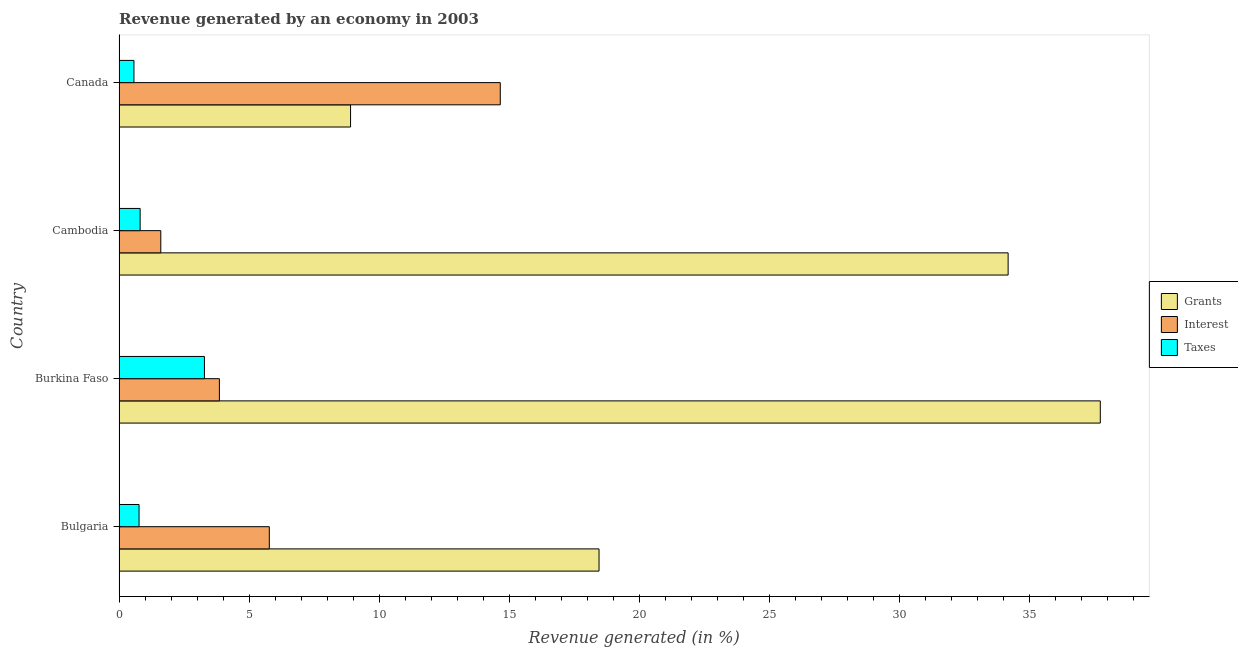How many groups of bars are there?
Keep it short and to the point. 4. Are the number of bars on each tick of the Y-axis equal?
Give a very brief answer. Yes. How many bars are there on the 3rd tick from the bottom?
Your answer should be very brief. 3. What is the label of the 1st group of bars from the top?
Offer a very short reply. Canada. What is the percentage of revenue generated by taxes in Canada?
Give a very brief answer. 0.57. Across all countries, what is the maximum percentage of revenue generated by grants?
Your answer should be compact. 37.71. Across all countries, what is the minimum percentage of revenue generated by grants?
Keep it short and to the point. 8.9. In which country was the percentage of revenue generated by taxes minimum?
Ensure brevity in your answer.  Canada. What is the total percentage of revenue generated by grants in the graph?
Offer a terse response. 99.23. What is the difference between the percentage of revenue generated by interest in Bulgaria and that in Cambodia?
Make the answer very short. 4.17. What is the difference between the percentage of revenue generated by taxes in Bulgaria and the percentage of revenue generated by grants in Canada?
Your answer should be compact. -8.13. What is the average percentage of revenue generated by interest per country?
Your answer should be very brief. 6.47. What is the difference between the percentage of revenue generated by interest and percentage of revenue generated by taxes in Bulgaria?
Provide a succinct answer. 5.01. In how many countries, is the percentage of revenue generated by interest greater than 4 %?
Your answer should be very brief. 2. What is the ratio of the percentage of revenue generated by interest in Cambodia to that in Canada?
Keep it short and to the point. 0.11. Is the difference between the percentage of revenue generated by grants in Bulgaria and Cambodia greater than the difference between the percentage of revenue generated by interest in Bulgaria and Cambodia?
Your answer should be compact. No. What is the difference between the highest and the second highest percentage of revenue generated by taxes?
Offer a terse response. 2.47. What is the difference between the highest and the lowest percentage of revenue generated by interest?
Your answer should be compact. 13.05. What does the 1st bar from the top in Burkina Faso represents?
Your answer should be compact. Taxes. What does the 2nd bar from the bottom in Bulgaria represents?
Keep it short and to the point. Interest. Is it the case that in every country, the sum of the percentage of revenue generated by grants and percentage of revenue generated by interest is greater than the percentage of revenue generated by taxes?
Provide a short and direct response. Yes. How many bars are there?
Provide a succinct answer. 12. Are all the bars in the graph horizontal?
Give a very brief answer. Yes. What is the difference between two consecutive major ticks on the X-axis?
Offer a very short reply. 5. Does the graph contain any zero values?
Provide a short and direct response. No. Where does the legend appear in the graph?
Provide a succinct answer. Center right. What is the title of the graph?
Make the answer very short. Revenue generated by an economy in 2003. What is the label or title of the X-axis?
Ensure brevity in your answer.  Revenue generated (in %). What is the label or title of the Y-axis?
Your answer should be very brief. Country. What is the Revenue generated (in %) of Grants in Bulgaria?
Your answer should be compact. 18.45. What is the Revenue generated (in %) of Interest in Bulgaria?
Provide a succinct answer. 5.78. What is the Revenue generated (in %) in Taxes in Bulgaria?
Offer a terse response. 0.77. What is the Revenue generated (in %) in Grants in Burkina Faso?
Keep it short and to the point. 37.71. What is the Revenue generated (in %) in Interest in Burkina Faso?
Keep it short and to the point. 3.86. What is the Revenue generated (in %) in Taxes in Burkina Faso?
Provide a succinct answer. 3.28. What is the Revenue generated (in %) of Grants in Cambodia?
Make the answer very short. 34.17. What is the Revenue generated (in %) in Interest in Cambodia?
Your answer should be very brief. 1.6. What is the Revenue generated (in %) in Taxes in Cambodia?
Ensure brevity in your answer.  0.81. What is the Revenue generated (in %) in Grants in Canada?
Your answer should be very brief. 8.9. What is the Revenue generated (in %) in Interest in Canada?
Give a very brief answer. 14.65. What is the Revenue generated (in %) in Taxes in Canada?
Your answer should be very brief. 0.57. Across all countries, what is the maximum Revenue generated (in %) of Grants?
Offer a terse response. 37.71. Across all countries, what is the maximum Revenue generated (in %) of Interest?
Your answer should be very brief. 14.65. Across all countries, what is the maximum Revenue generated (in %) of Taxes?
Offer a very short reply. 3.28. Across all countries, what is the minimum Revenue generated (in %) in Grants?
Make the answer very short. 8.9. Across all countries, what is the minimum Revenue generated (in %) in Interest?
Ensure brevity in your answer.  1.6. Across all countries, what is the minimum Revenue generated (in %) of Taxes?
Ensure brevity in your answer.  0.57. What is the total Revenue generated (in %) of Grants in the graph?
Your answer should be very brief. 99.23. What is the total Revenue generated (in %) in Interest in the graph?
Your answer should be compact. 25.89. What is the total Revenue generated (in %) of Taxes in the graph?
Give a very brief answer. 5.43. What is the difference between the Revenue generated (in %) in Grants in Bulgaria and that in Burkina Faso?
Provide a short and direct response. -19.27. What is the difference between the Revenue generated (in %) in Interest in Bulgaria and that in Burkina Faso?
Your answer should be very brief. 1.92. What is the difference between the Revenue generated (in %) in Taxes in Bulgaria and that in Burkina Faso?
Provide a succinct answer. -2.51. What is the difference between the Revenue generated (in %) of Grants in Bulgaria and that in Cambodia?
Give a very brief answer. -15.72. What is the difference between the Revenue generated (in %) of Interest in Bulgaria and that in Cambodia?
Provide a short and direct response. 4.17. What is the difference between the Revenue generated (in %) of Taxes in Bulgaria and that in Cambodia?
Provide a succinct answer. -0.04. What is the difference between the Revenue generated (in %) in Grants in Bulgaria and that in Canada?
Your answer should be very brief. 9.55. What is the difference between the Revenue generated (in %) of Interest in Bulgaria and that in Canada?
Give a very brief answer. -8.88. What is the difference between the Revenue generated (in %) in Taxes in Bulgaria and that in Canada?
Make the answer very short. 0.2. What is the difference between the Revenue generated (in %) of Grants in Burkina Faso and that in Cambodia?
Provide a succinct answer. 3.54. What is the difference between the Revenue generated (in %) in Interest in Burkina Faso and that in Cambodia?
Ensure brevity in your answer.  2.25. What is the difference between the Revenue generated (in %) in Taxes in Burkina Faso and that in Cambodia?
Offer a very short reply. 2.47. What is the difference between the Revenue generated (in %) in Grants in Burkina Faso and that in Canada?
Your answer should be very brief. 28.82. What is the difference between the Revenue generated (in %) of Interest in Burkina Faso and that in Canada?
Your response must be concise. -10.8. What is the difference between the Revenue generated (in %) in Taxes in Burkina Faso and that in Canada?
Give a very brief answer. 2.71. What is the difference between the Revenue generated (in %) of Grants in Cambodia and that in Canada?
Provide a succinct answer. 25.27. What is the difference between the Revenue generated (in %) in Interest in Cambodia and that in Canada?
Offer a terse response. -13.05. What is the difference between the Revenue generated (in %) of Taxes in Cambodia and that in Canada?
Offer a very short reply. 0.24. What is the difference between the Revenue generated (in %) of Grants in Bulgaria and the Revenue generated (in %) of Interest in Burkina Faso?
Offer a terse response. 14.59. What is the difference between the Revenue generated (in %) of Grants in Bulgaria and the Revenue generated (in %) of Taxes in Burkina Faso?
Ensure brevity in your answer.  15.17. What is the difference between the Revenue generated (in %) in Interest in Bulgaria and the Revenue generated (in %) in Taxes in Burkina Faso?
Make the answer very short. 2.49. What is the difference between the Revenue generated (in %) in Grants in Bulgaria and the Revenue generated (in %) in Interest in Cambodia?
Provide a succinct answer. 16.84. What is the difference between the Revenue generated (in %) in Grants in Bulgaria and the Revenue generated (in %) in Taxes in Cambodia?
Provide a short and direct response. 17.64. What is the difference between the Revenue generated (in %) of Interest in Bulgaria and the Revenue generated (in %) of Taxes in Cambodia?
Offer a very short reply. 4.96. What is the difference between the Revenue generated (in %) of Grants in Bulgaria and the Revenue generated (in %) of Interest in Canada?
Your answer should be compact. 3.8. What is the difference between the Revenue generated (in %) of Grants in Bulgaria and the Revenue generated (in %) of Taxes in Canada?
Offer a very short reply. 17.87. What is the difference between the Revenue generated (in %) of Interest in Bulgaria and the Revenue generated (in %) of Taxes in Canada?
Provide a short and direct response. 5.2. What is the difference between the Revenue generated (in %) in Grants in Burkina Faso and the Revenue generated (in %) in Interest in Cambodia?
Provide a short and direct response. 36.11. What is the difference between the Revenue generated (in %) in Grants in Burkina Faso and the Revenue generated (in %) in Taxes in Cambodia?
Offer a terse response. 36.9. What is the difference between the Revenue generated (in %) of Interest in Burkina Faso and the Revenue generated (in %) of Taxes in Cambodia?
Make the answer very short. 3.05. What is the difference between the Revenue generated (in %) of Grants in Burkina Faso and the Revenue generated (in %) of Interest in Canada?
Your answer should be compact. 23.06. What is the difference between the Revenue generated (in %) in Grants in Burkina Faso and the Revenue generated (in %) in Taxes in Canada?
Offer a very short reply. 37.14. What is the difference between the Revenue generated (in %) in Interest in Burkina Faso and the Revenue generated (in %) in Taxes in Canada?
Your answer should be compact. 3.28. What is the difference between the Revenue generated (in %) in Grants in Cambodia and the Revenue generated (in %) in Interest in Canada?
Offer a terse response. 19.52. What is the difference between the Revenue generated (in %) of Grants in Cambodia and the Revenue generated (in %) of Taxes in Canada?
Your answer should be very brief. 33.6. What is the difference between the Revenue generated (in %) in Interest in Cambodia and the Revenue generated (in %) in Taxes in Canada?
Ensure brevity in your answer.  1.03. What is the average Revenue generated (in %) of Grants per country?
Your answer should be compact. 24.81. What is the average Revenue generated (in %) of Interest per country?
Keep it short and to the point. 6.47. What is the average Revenue generated (in %) of Taxes per country?
Your answer should be very brief. 1.36. What is the difference between the Revenue generated (in %) of Grants and Revenue generated (in %) of Interest in Bulgaria?
Offer a terse response. 12.67. What is the difference between the Revenue generated (in %) of Grants and Revenue generated (in %) of Taxes in Bulgaria?
Ensure brevity in your answer.  17.68. What is the difference between the Revenue generated (in %) of Interest and Revenue generated (in %) of Taxes in Bulgaria?
Your response must be concise. 5.01. What is the difference between the Revenue generated (in %) in Grants and Revenue generated (in %) in Interest in Burkina Faso?
Offer a terse response. 33.86. What is the difference between the Revenue generated (in %) of Grants and Revenue generated (in %) of Taxes in Burkina Faso?
Provide a succinct answer. 34.43. What is the difference between the Revenue generated (in %) of Interest and Revenue generated (in %) of Taxes in Burkina Faso?
Your answer should be compact. 0.57. What is the difference between the Revenue generated (in %) in Grants and Revenue generated (in %) in Interest in Cambodia?
Your response must be concise. 32.57. What is the difference between the Revenue generated (in %) in Grants and Revenue generated (in %) in Taxes in Cambodia?
Your response must be concise. 33.36. What is the difference between the Revenue generated (in %) of Interest and Revenue generated (in %) of Taxes in Cambodia?
Provide a succinct answer. 0.79. What is the difference between the Revenue generated (in %) of Grants and Revenue generated (in %) of Interest in Canada?
Offer a very short reply. -5.75. What is the difference between the Revenue generated (in %) of Grants and Revenue generated (in %) of Taxes in Canada?
Your answer should be very brief. 8.32. What is the difference between the Revenue generated (in %) of Interest and Revenue generated (in %) of Taxes in Canada?
Offer a terse response. 14.08. What is the ratio of the Revenue generated (in %) in Grants in Bulgaria to that in Burkina Faso?
Your answer should be compact. 0.49. What is the ratio of the Revenue generated (in %) of Interest in Bulgaria to that in Burkina Faso?
Provide a short and direct response. 1.5. What is the ratio of the Revenue generated (in %) in Taxes in Bulgaria to that in Burkina Faso?
Your answer should be compact. 0.23. What is the ratio of the Revenue generated (in %) in Grants in Bulgaria to that in Cambodia?
Provide a short and direct response. 0.54. What is the ratio of the Revenue generated (in %) of Interest in Bulgaria to that in Cambodia?
Your answer should be very brief. 3.6. What is the ratio of the Revenue generated (in %) of Taxes in Bulgaria to that in Cambodia?
Your answer should be very brief. 0.95. What is the ratio of the Revenue generated (in %) in Grants in Bulgaria to that in Canada?
Your answer should be compact. 2.07. What is the ratio of the Revenue generated (in %) of Interest in Bulgaria to that in Canada?
Keep it short and to the point. 0.39. What is the ratio of the Revenue generated (in %) of Taxes in Bulgaria to that in Canada?
Your response must be concise. 1.34. What is the ratio of the Revenue generated (in %) in Grants in Burkina Faso to that in Cambodia?
Offer a terse response. 1.1. What is the ratio of the Revenue generated (in %) of Interest in Burkina Faso to that in Cambodia?
Make the answer very short. 2.4. What is the ratio of the Revenue generated (in %) of Taxes in Burkina Faso to that in Cambodia?
Offer a very short reply. 4.05. What is the ratio of the Revenue generated (in %) in Grants in Burkina Faso to that in Canada?
Provide a succinct answer. 4.24. What is the ratio of the Revenue generated (in %) in Interest in Burkina Faso to that in Canada?
Your response must be concise. 0.26. What is the ratio of the Revenue generated (in %) of Taxes in Burkina Faso to that in Canada?
Provide a succinct answer. 5.73. What is the ratio of the Revenue generated (in %) in Grants in Cambodia to that in Canada?
Give a very brief answer. 3.84. What is the ratio of the Revenue generated (in %) in Interest in Cambodia to that in Canada?
Keep it short and to the point. 0.11. What is the ratio of the Revenue generated (in %) in Taxes in Cambodia to that in Canada?
Provide a succinct answer. 1.41. What is the difference between the highest and the second highest Revenue generated (in %) in Grants?
Offer a very short reply. 3.54. What is the difference between the highest and the second highest Revenue generated (in %) of Interest?
Provide a short and direct response. 8.88. What is the difference between the highest and the second highest Revenue generated (in %) in Taxes?
Offer a terse response. 2.47. What is the difference between the highest and the lowest Revenue generated (in %) in Grants?
Keep it short and to the point. 28.82. What is the difference between the highest and the lowest Revenue generated (in %) of Interest?
Offer a very short reply. 13.05. What is the difference between the highest and the lowest Revenue generated (in %) of Taxes?
Your answer should be compact. 2.71. 